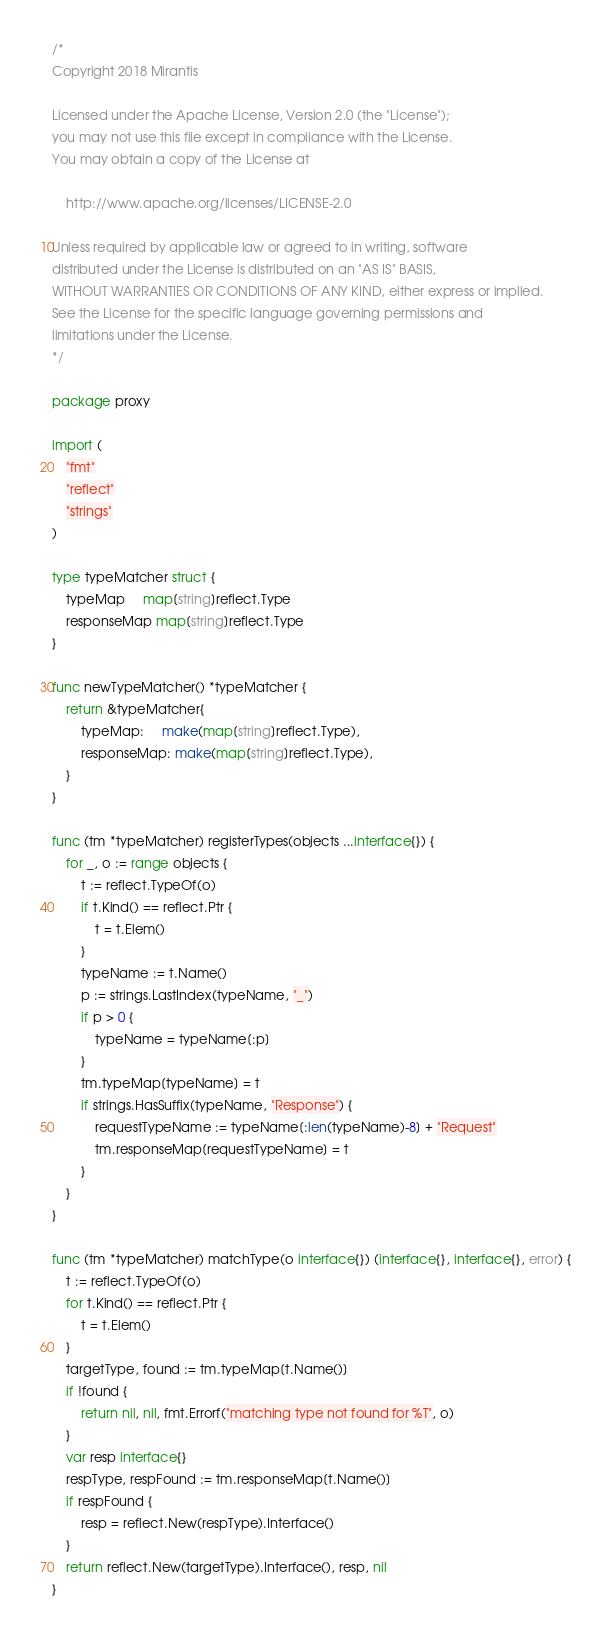Convert code to text. <code><loc_0><loc_0><loc_500><loc_500><_Go_>/*
Copyright 2018 Mirantis

Licensed under the Apache License, Version 2.0 (the "License");
you may not use this file except in compliance with the License.
You may obtain a copy of the License at

    http://www.apache.org/licenses/LICENSE-2.0

Unless required by applicable law or agreed to in writing, software
distributed under the License is distributed on an "AS IS" BASIS,
WITHOUT WARRANTIES OR CONDITIONS OF ANY KIND, either express or implied.
See the License for the specific language governing permissions and
limitations under the License.
*/

package proxy

import (
	"fmt"
	"reflect"
	"strings"
)

type typeMatcher struct {
	typeMap     map[string]reflect.Type
	responseMap map[string]reflect.Type
}

func newTypeMatcher() *typeMatcher {
	return &typeMatcher{
		typeMap:     make(map[string]reflect.Type),
		responseMap: make(map[string]reflect.Type),
	}
}

func (tm *typeMatcher) registerTypes(objects ...interface{}) {
	for _, o := range objects {
		t := reflect.TypeOf(o)
		if t.Kind() == reflect.Ptr {
			t = t.Elem()
		}
		typeName := t.Name()
		p := strings.LastIndex(typeName, "_")
		if p > 0 {
			typeName = typeName[:p]
		}
		tm.typeMap[typeName] = t
		if strings.HasSuffix(typeName, "Response") {
			requestTypeName := typeName[:len(typeName)-8] + "Request"
			tm.responseMap[requestTypeName] = t
		}
	}
}

func (tm *typeMatcher) matchType(o interface{}) (interface{}, interface{}, error) {
	t := reflect.TypeOf(o)
	for t.Kind() == reflect.Ptr {
		t = t.Elem()
	}
	targetType, found := tm.typeMap[t.Name()]
	if !found {
		return nil, nil, fmt.Errorf("matching type not found for %T", o)
	}
	var resp interface{}
	respType, respFound := tm.responseMap[t.Name()]
	if respFound {
		resp = reflect.New(respType).Interface()
	}
	return reflect.New(targetType).Interface(), resp, nil
}
</code> 